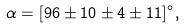<formula> <loc_0><loc_0><loc_500><loc_500>\alpha = [ 9 6 \pm 1 0 \pm 4 \pm { 1 1 } ] ^ { \circ } ,</formula> 